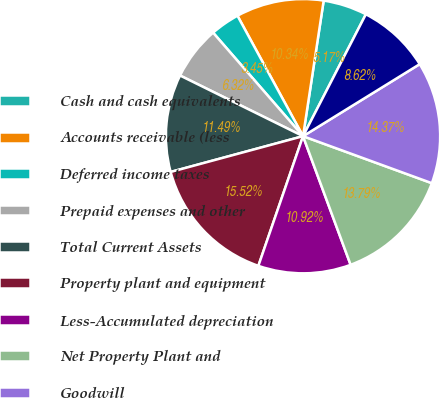Convert chart to OTSL. <chart><loc_0><loc_0><loc_500><loc_500><pie_chart><fcel>Cash and cash equivalents<fcel>Accounts receivable (less<fcel>Deferred income taxes<fcel>Prepaid expenses and other<fcel>Total Current Assets<fcel>Property plant and equipment<fcel>Less-Accumulated depreciation<fcel>Net Property Plant and<fcel>Goodwill<fcel>Customer relationships and<nl><fcel>5.17%<fcel>10.34%<fcel>3.45%<fcel>6.32%<fcel>11.49%<fcel>15.52%<fcel>10.92%<fcel>13.79%<fcel>14.37%<fcel>8.62%<nl></chart> 